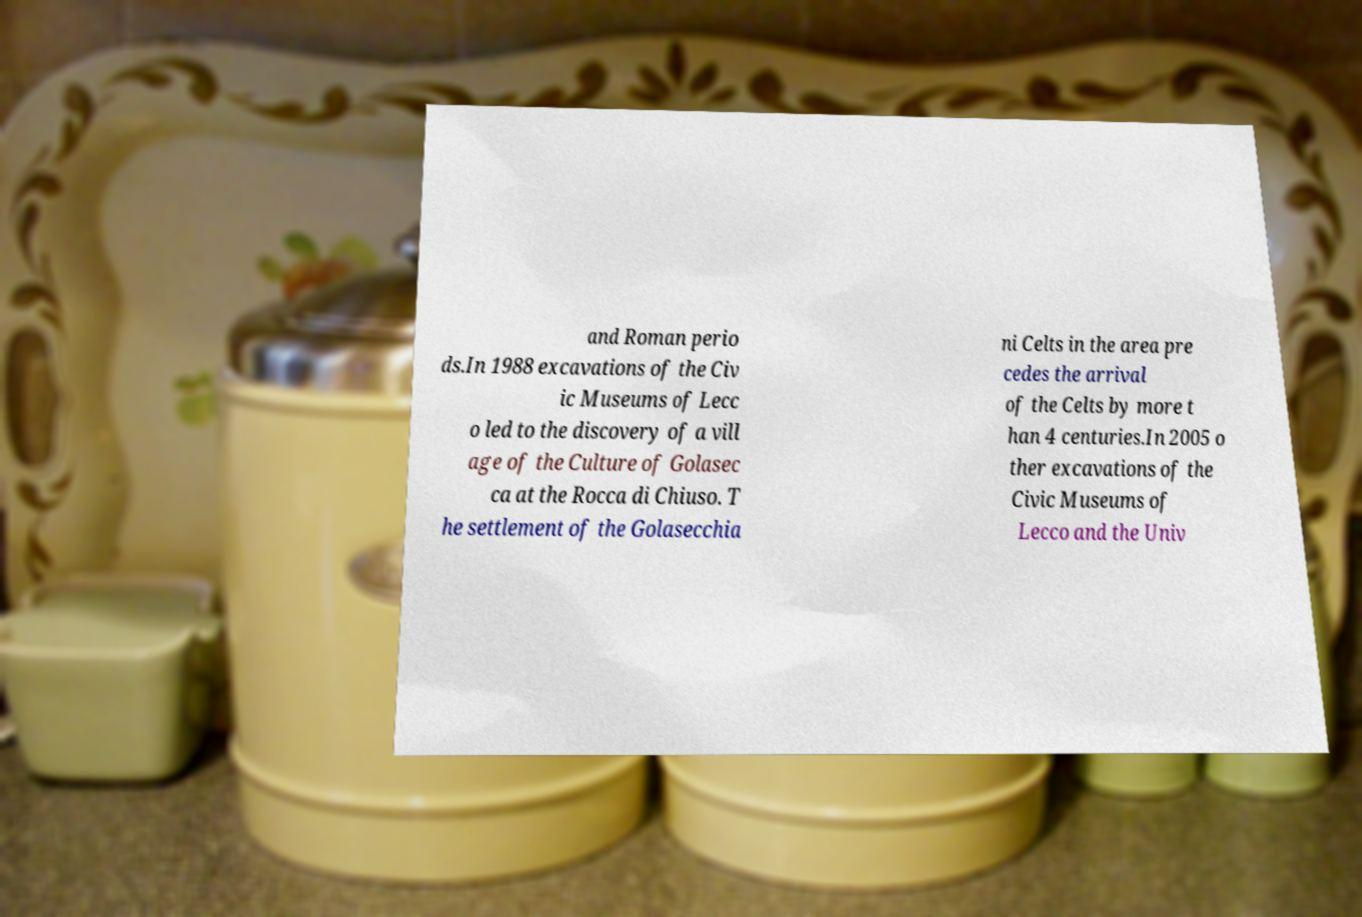Can you read and provide the text displayed in the image?This photo seems to have some interesting text. Can you extract and type it out for me? and Roman perio ds.In 1988 excavations of the Civ ic Museums of Lecc o led to the discovery of a vill age of the Culture of Golasec ca at the Rocca di Chiuso. T he settlement of the Golasecchia ni Celts in the area pre cedes the arrival of the Celts by more t han 4 centuries.In 2005 o ther excavations of the Civic Museums of Lecco and the Univ 